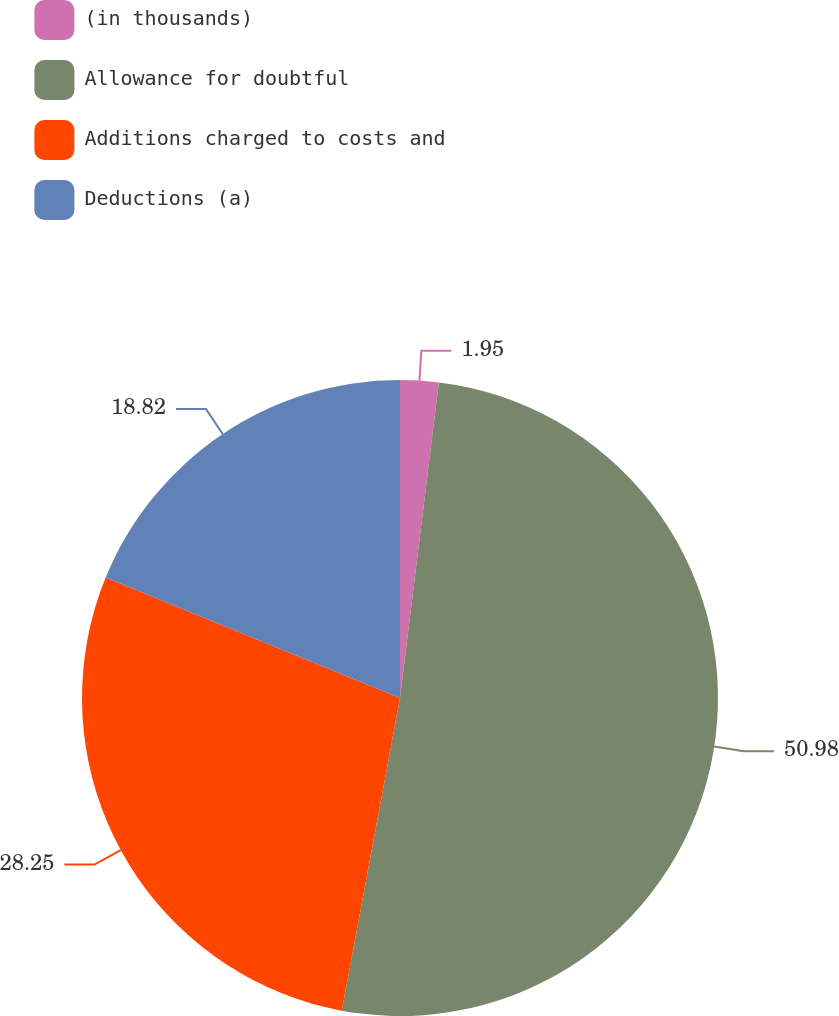<chart> <loc_0><loc_0><loc_500><loc_500><pie_chart><fcel>(in thousands)<fcel>Allowance for doubtful<fcel>Additions charged to costs and<fcel>Deductions (a)<nl><fcel>1.95%<fcel>50.98%<fcel>28.25%<fcel>18.82%<nl></chart> 